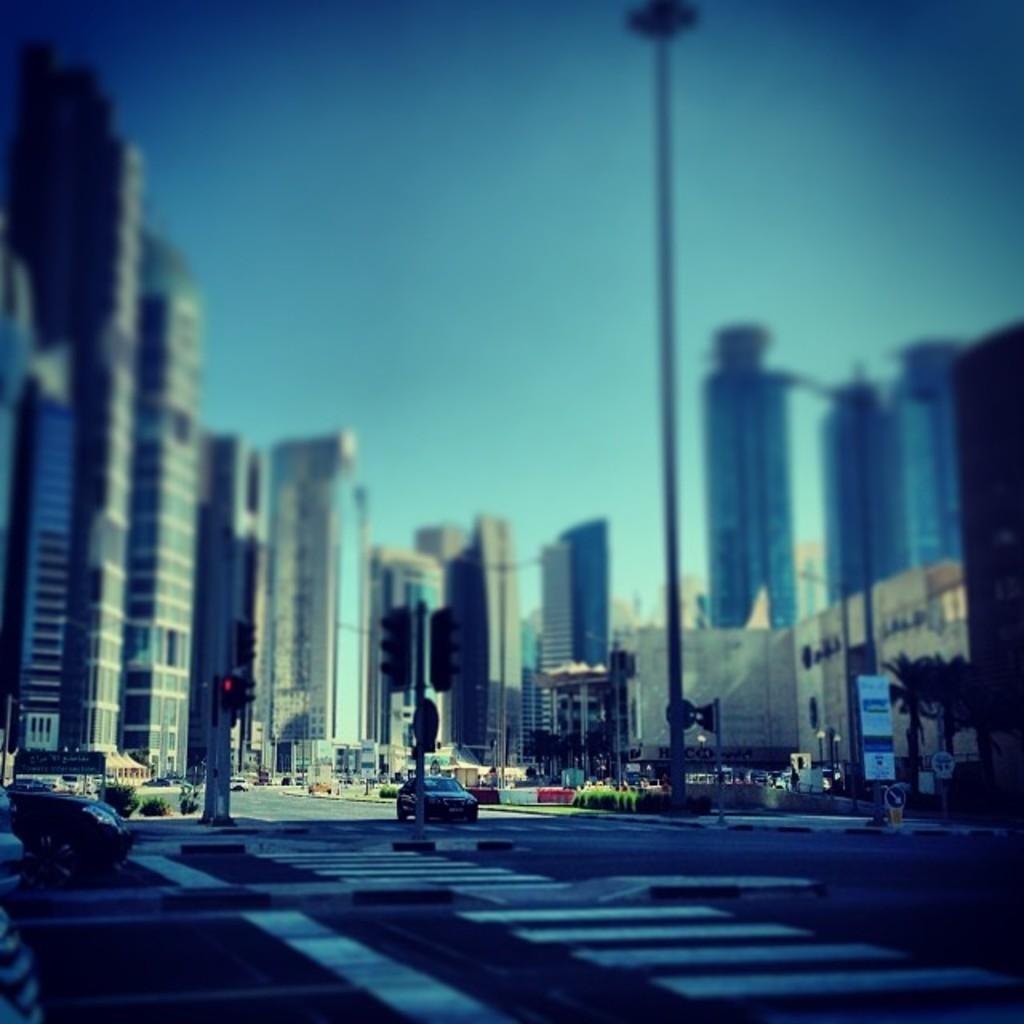Describe this image in one or two sentences. In this image we can see sky, buildings, sign boards, trees, shrubs, traffic poles, traffic signals and motor vehicles on the road. 